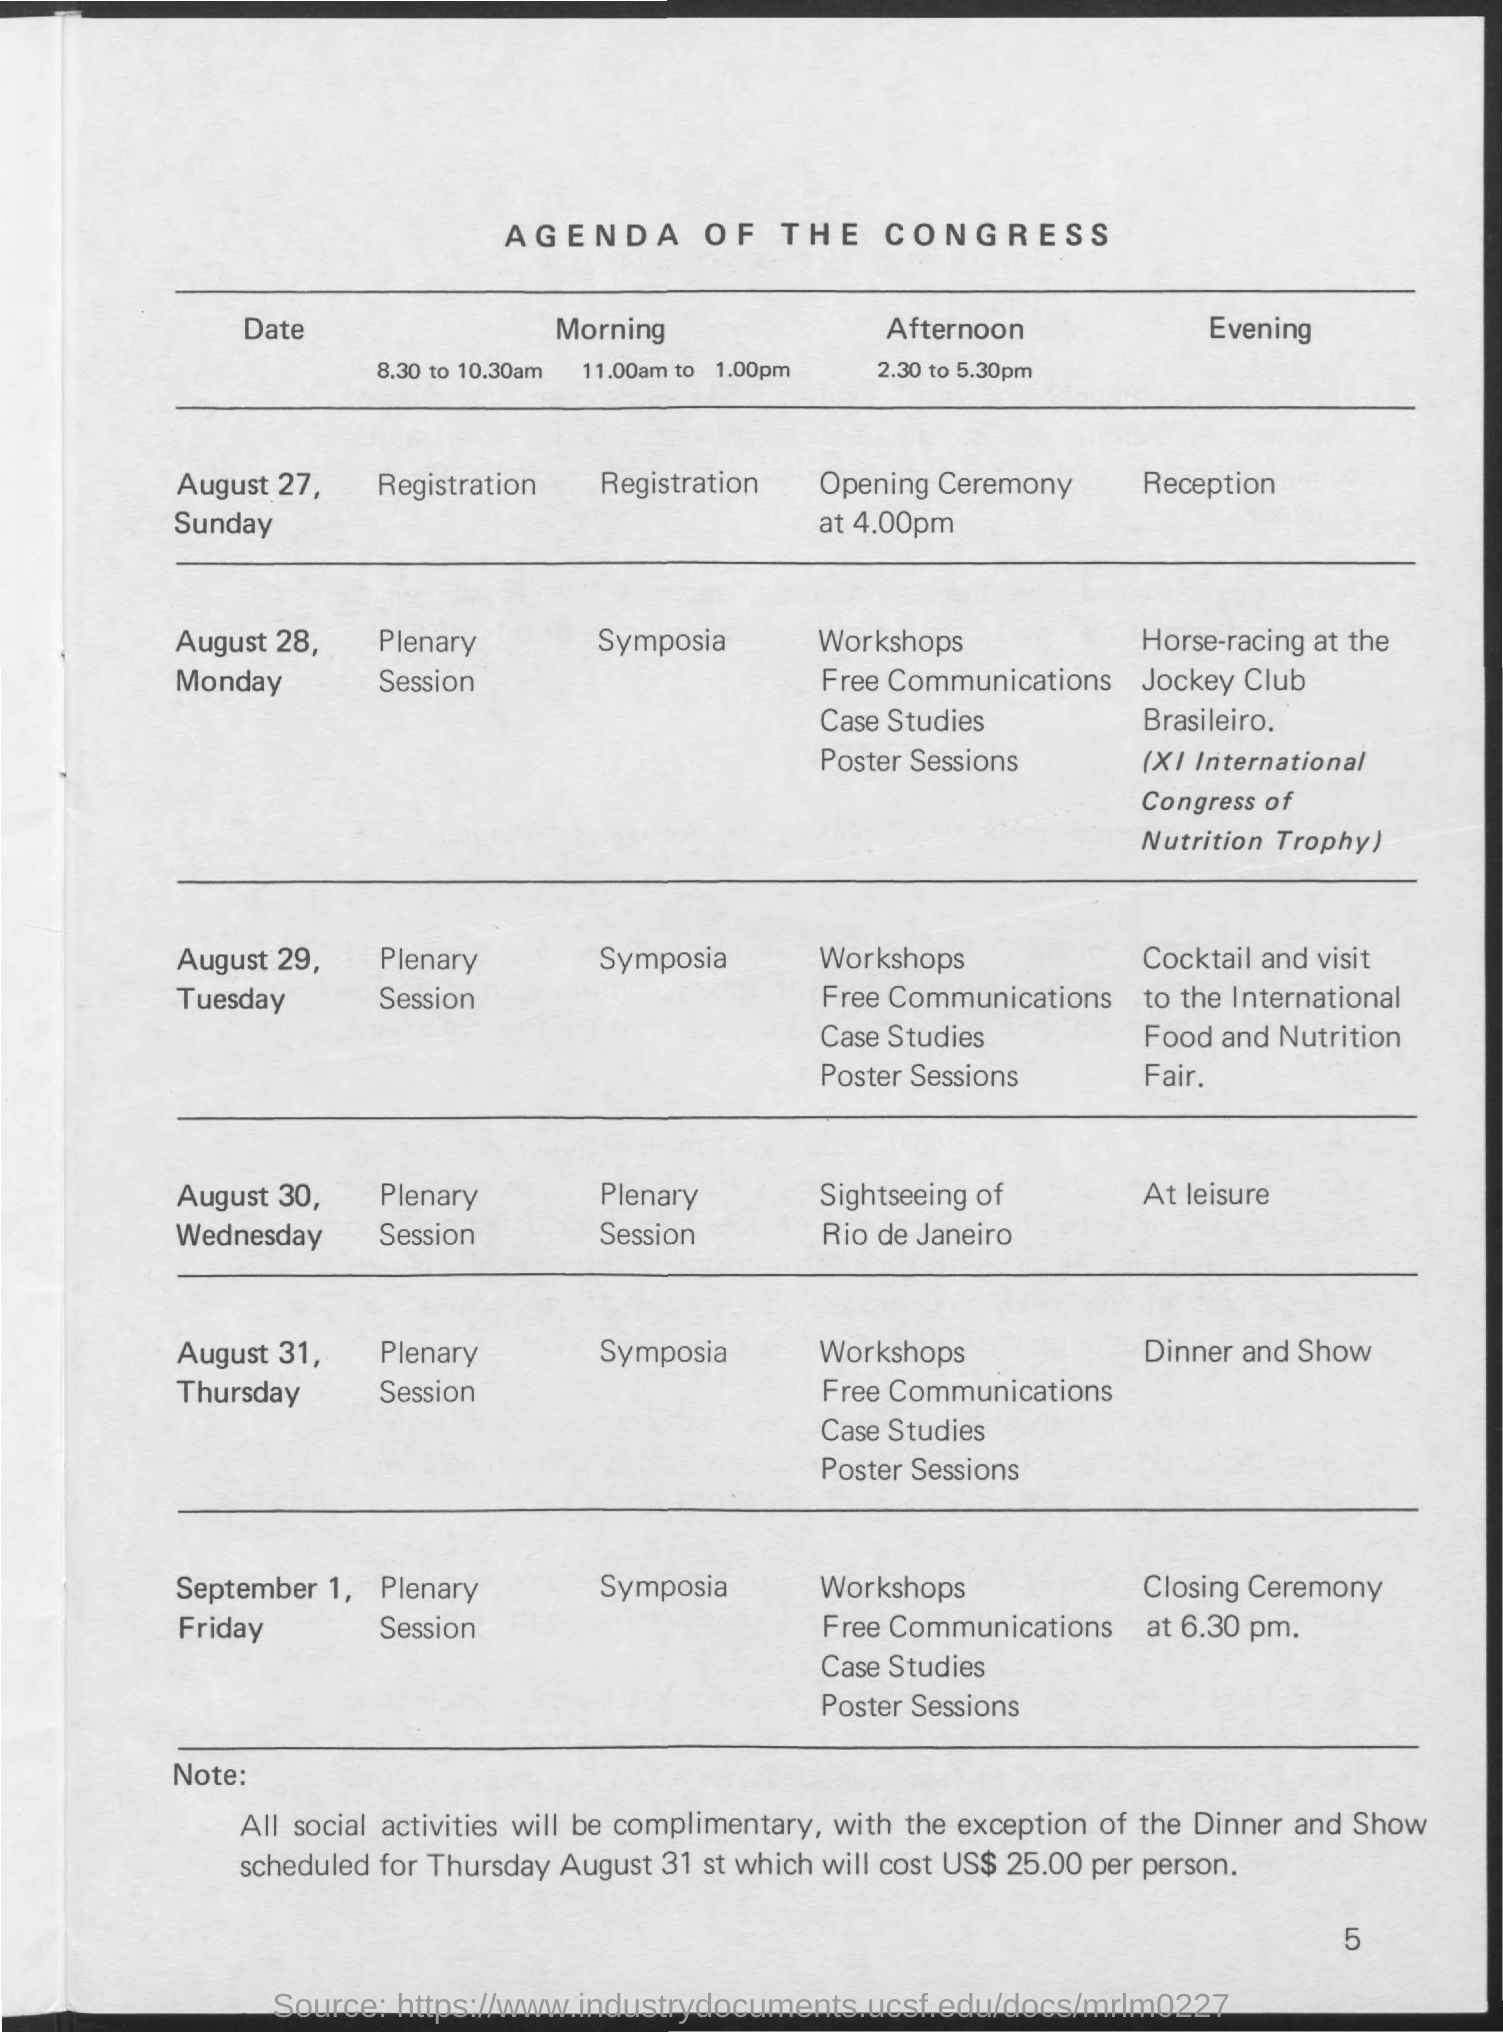Highlight a few significant elements in this photo. The title of the document is the Agenda of the Congress. 